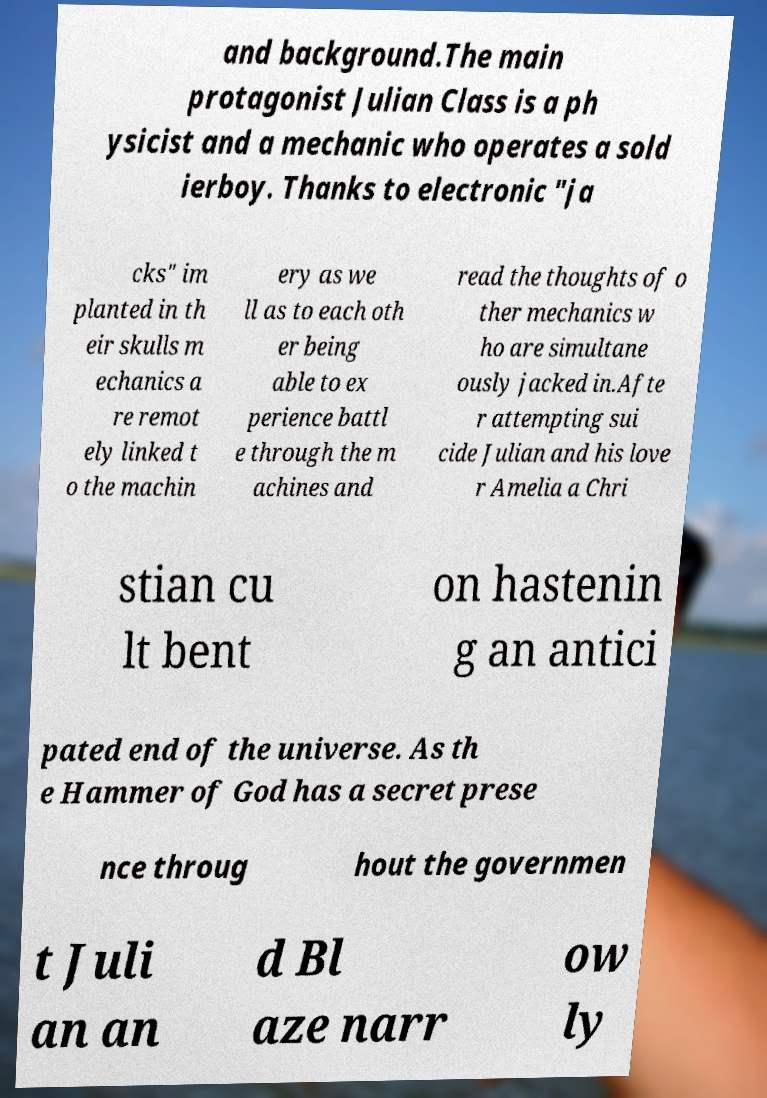There's text embedded in this image that I need extracted. Can you transcribe it verbatim? and background.The main protagonist Julian Class is a ph ysicist and a mechanic who operates a sold ierboy. Thanks to electronic "ja cks" im planted in th eir skulls m echanics a re remot ely linked t o the machin ery as we ll as to each oth er being able to ex perience battl e through the m achines and read the thoughts of o ther mechanics w ho are simultane ously jacked in.Afte r attempting sui cide Julian and his love r Amelia a Chri stian cu lt bent on hastenin g an antici pated end of the universe. As th e Hammer of God has a secret prese nce throug hout the governmen t Juli an an d Bl aze narr ow ly 